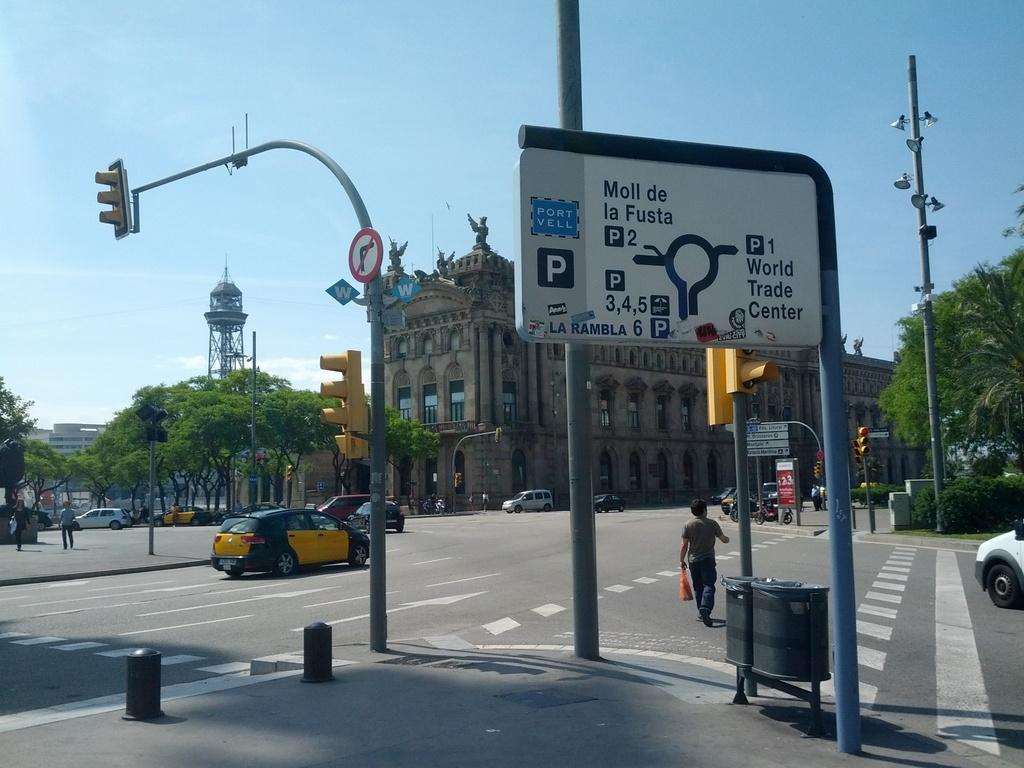<image>
Create a compact narrative representing the image presented. a port vell sign that is next to the street 